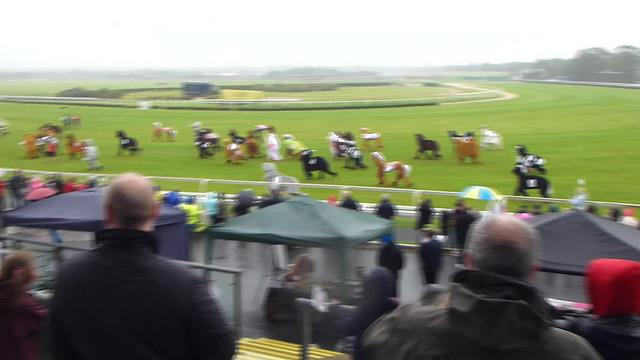How many awnings are there? Please explain your reasoning. three. You can see the coverings that there are three of them. 